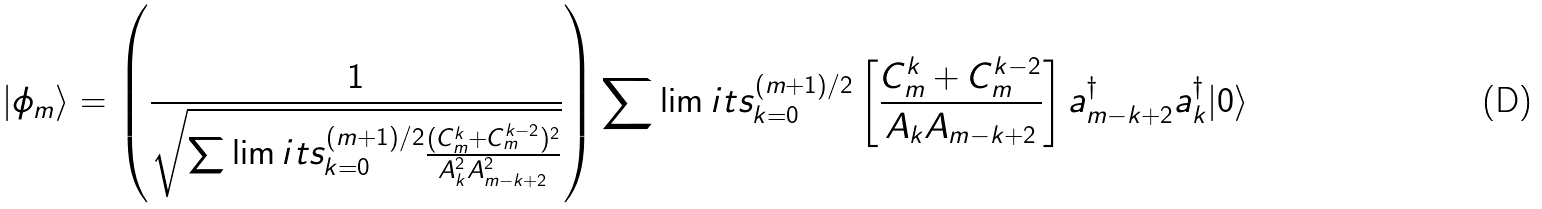Convert formula to latex. <formula><loc_0><loc_0><loc_500><loc_500>| \phi _ { m } \rangle = \left ( \frac { 1 } { \sqrt { \sum \lim i t s _ { k = 0 } ^ { ( m + 1 ) / 2 } \frac { ( C _ { m } ^ { k } + C _ { m } ^ { k - 2 } ) ^ { 2 } } { A _ { k } ^ { 2 } A _ { m - k + 2 } ^ { 2 } } } } \right ) \sum \lim i t s _ { k = 0 } ^ { ( m + 1 ) / 2 } \left [ \frac { C _ { m } ^ { k } + C _ { m } ^ { k - 2 } } { A _ { k } A _ { m - k + 2 } } \right ] a _ { m - k + 2 } ^ { \dag } a _ { k } ^ { \dag } | 0 \rangle</formula> 